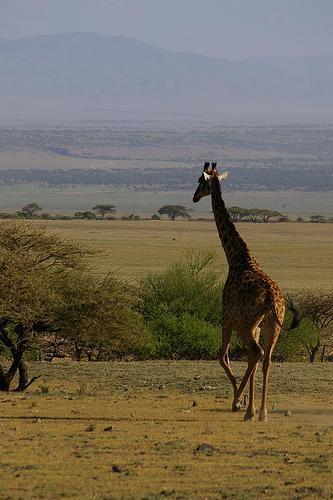How many giraffes are there?
Give a very brief answer. 1. How many tails does a giraffe have?
Give a very brief answer. 1. 